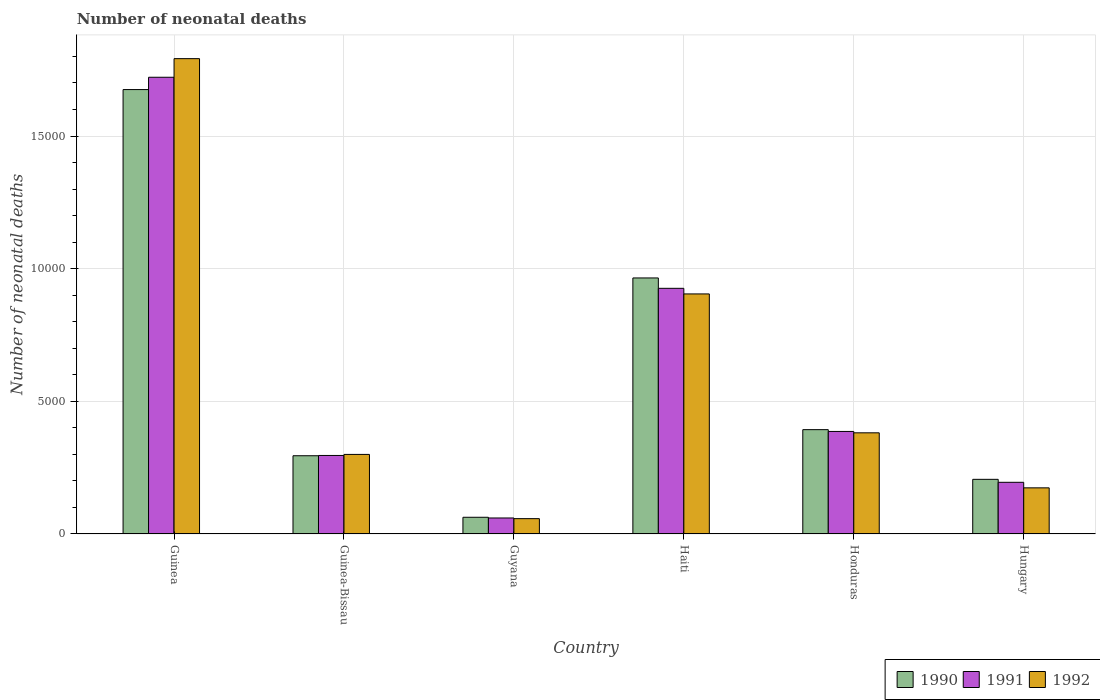How many groups of bars are there?
Provide a succinct answer. 6. Are the number of bars per tick equal to the number of legend labels?
Offer a very short reply. Yes. How many bars are there on the 3rd tick from the right?
Ensure brevity in your answer.  3. What is the label of the 2nd group of bars from the left?
Provide a short and direct response. Guinea-Bissau. What is the number of neonatal deaths in in 1992 in Haiti?
Keep it short and to the point. 9049. Across all countries, what is the maximum number of neonatal deaths in in 1992?
Provide a succinct answer. 1.79e+04. Across all countries, what is the minimum number of neonatal deaths in in 1991?
Offer a very short reply. 603. In which country was the number of neonatal deaths in in 1992 maximum?
Your answer should be compact. Guinea. In which country was the number of neonatal deaths in in 1990 minimum?
Offer a terse response. Guyana. What is the total number of neonatal deaths in in 1992 in the graph?
Keep it short and to the point. 3.61e+04. What is the difference between the number of neonatal deaths in in 1992 in Guinea and that in Guyana?
Keep it short and to the point. 1.73e+04. What is the difference between the number of neonatal deaths in in 1991 in Guinea-Bissau and the number of neonatal deaths in in 1990 in Guinea?
Your answer should be very brief. -1.38e+04. What is the average number of neonatal deaths in in 1990 per country?
Offer a very short reply. 5995.83. What is the difference between the number of neonatal deaths in of/in 1992 and number of neonatal deaths in of/in 1991 in Haiti?
Offer a terse response. -211. What is the ratio of the number of neonatal deaths in in 1991 in Guinea to that in Guinea-Bissau?
Your answer should be compact. 5.82. Is the difference between the number of neonatal deaths in in 1992 in Guinea-Bissau and Guyana greater than the difference between the number of neonatal deaths in in 1991 in Guinea-Bissau and Guyana?
Your answer should be compact. Yes. What is the difference between the highest and the second highest number of neonatal deaths in in 1992?
Ensure brevity in your answer.  5236. What is the difference between the highest and the lowest number of neonatal deaths in in 1992?
Keep it short and to the point. 1.73e+04. In how many countries, is the number of neonatal deaths in in 1992 greater than the average number of neonatal deaths in in 1992 taken over all countries?
Your answer should be compact. 2. Is the sum of the number of neonatal deaths in in 1991 in Guyana and Hungary greater than the maximum number of neonatal deaths in in 1992 across all countries?
Your answer should be compact. No. What does the 1st bar from the left in Guyana represents?
Provide a short and direct response. 1990. Is it the case that in every country, the sum of the number of neonatal deaths in in 1990 and number of neonatal deaths in in 1992 is greater than the number of neonatal deaths in in 1991?
Ensure brevity in your answer.  Yes. Are all the bars in the graph horizontal?
Your answer should be very brief. No. What is the difference between two consecutive major ticks on the Y-axis?
Your answer should be compact. 5000. Are the values on the major ticks of Y-axis written in scientific E-notation?
Offer a terse response. No. Does the graph contain grids?
Provide a short and direct response. Yes. Where does the legend appear in the graph?
Offer a terse response. Bottom right. How many legend labels are there?
Your answer should be very brief. 3. What is the title of the graph?
Give a very brief answer. Number of neonatal deaths. Does "2003" appear as one of the legend labels in the graph?
Ensure brevity in your answer.  No. What is the label or title of the Y-axis?
Your answer should be very brief. Number of neonatal deaths. What is the Number of neonatal deaths of 1990 in Guinea?
Keep it short and to the point. 1.68e+04. What is the Number of neonatal deaths of 1991 in Guinea?
Offer a very short reply. 1.72e+04. What is the Number of neonatal deaths in 1992 in Guinea?
Make the answer very short. 1.79e+04. What is the Number of neonatal deaths in 1990 in Guinea-Bissau?
Keep it short and to the point. 2949. What is the Number of neonatal deaths of 1991 in Guinea-Bissau?
Offer a very short reply. 2960. What is the Number of neonatal deaths in 1992 in Guinea-Bissau?
Keep it short and to the point. 2999. What is the Number of neonatal deaths in 1990 in Guyana?
Offer a terse response. 630. What is the Number of neonatal deaths of 1991 in Guyana?
Give a very brief answer. 603. What is the Number of neonatal deaths of 1992 in Guyana?
Your answer should be compact. 578. What is the Number of neonatal deaths in 1990 in Haiti?
Your answer should be very brief. 9651. What is the Number of neonatal deaths in 1991 in Haiti?
Ensure brevity in your answer.  9260. What is the Number of neonatal deaths of 1992 in Haiti?
Offer a terse response. 9049. What is the Number of neonatal deaths of 1990 in Honduras?
Give a very brief answer. 3933. What is the Number of neonatal deaths in 1991 in Honduras?
Ensure brevity in your answer.  3865. What is the Number of neonatal deaths of 1992 in Honduras?
Your answer should be very brief. 3813. What is the Number of neonatal deaths in 1990 in Hungary?
Your response must be concise. 2060. What is the Number of neonatal deaths in 1991 in Hungary?
Offer a terse response. 1948. What is the Number of neonatal deaths of 1992 in Hungary?
Keep it short and to the point. 1739. Across all countries, what is the maximum Number of neonatal deaths of 1990?
Give a very brief answer. 1.68e+04. Across all countries, what is the maximum Number of neonatal deaths of 1991?
Your answer should be very brief. 1.72e+04. Across all countries, what is the maximum Number of neonatal deaths of 1992?
Offer a terse response. 1.79e+04. Across all countries, what is the minimum Number of neonatal deaths in 1990?
Your answer should be very brief. 630. Across all countries, what is the minimum Number of neonatal deaths in 1991?
Offer a terse response. 603. Across all countries, what is the minimum Number of neonatal deaths in 1992?
Ensure brevity in your answer.  578. What is the total Number of neonatal deaths of 1990 in the graph?
Keep it short and to the point. 3.60e+04. What is the total Number of neonatal deaths of 1991 in the graph?
Your response must be concise. 3.59e+04. What is the total Number of neonatal deaths in 1992 in the graph?
Make the answer very short. 3.61e+04. What is the difference between the Number of neonatal deaths of 1990 in Guinea and that in Guinea-Bissau?
Keep it short and to the point. 1.38e+04. What is the difference between the Number of neonatal deaths of 1991 in Guinea and that in Guinea-Bissau?
Ensure brevity in your answer.  1.43e+04. What is the difference between the Number of neonatal deaths in 1992 in Guinea and that in Guinea-Bissau?
Keep it short and to the point. 1.49e+04. What is the difference between the Number of neonatal deaths in 1990 in Guinea and that in Guyana?
Offer a very short reply. 1.61e+04. What is the difference between the Number of neonatal deaths of 1991 in Guinea and that in Guyana?
Keep it short and to the point. 1.66e+04. What is the difference between the Number of neonatal deaths of 1992 in Guinea and that in Guyana?
Your answer should be very brief. 1.73e+04. What is the difference between the Number of neonatal deaths in 1990 in Guinea and that in Haiti?
Offer a very short reply. 7101. What is the difference between the Number of neonatal deaths in 1991 in Guinea and that in Haiti?
Provide a succinct answer. 7956. What is the difference between the Number of neonatal deaths in 1992 in Guinea and that in Haiti?
Give a very brief answer. 8869. What is the difference between the Number of neonatal deaths in 1990 in Guinea and that in Honduras?
Ensure brevity in your answer.  1.28e+04. What is the difference between the Number of neonatal deaths in 1991 in Guinea and that in Honduras?
Your response must be concise. 1.34e+04. What is the difference between the Number of neonatal deaths of 1992 in Guinea and that in Honduras?
Provide a short and direct response. 1.41e+04. What is the difference between the Number of neonatal deaths in 1990 in Guinea and that in Hungary?
Give a very brief answer. 1.47e+04. What is the difference between the Number of neonatal deaths in 1991 in Guinea and that in Hungary?
Provide a succinct answer. 1.53e+04. What is the difference between the Number of neonatal deaths of 1992 in Guinea and that in Hungary?
Provide a succinct answer. 1.62e+04. What is the difference between the Number of neonatal deaths of 1990 in Guinea-Bissau and that in Guyana?
Keep it short and to the point. 2319. What is the difference between the Number of neonatal deaths of 1991 in Guinea-Bissau and that in Guyana?
Your answer should be very brief. 2357. What is the difference between the Number of neonatal deaths in 1992 in Guinea-Bissau and that in Guyana?
Make the answer very short. 2421. What is the difference between the Number of neonatal deaths in 1990 in Guinea-Bissau and that in Haiti?
Provide a succinct answer. -6702. What is the difference between the Number of neonatal deaths in 1991 in Guinea-Bissau and that in Haiti?
Offer a terse response. -6300. What is the difference between the Number of neonatal deaths of 1992 in Guinea-Bissau and that in Haiti?
Offer a terse response. -6050. What is the difference between the Number of neonatal deaths in 1990 in Guinea-Bissau and that in Honduras?
Keep it short and to the point. -984. What is the difference between the Number of neonatal deaths in 1991 in Guinea-Bissau and that in Honduras?
Keep it short and to the point. -905. What is the difference between the Number of neonatal deaths of 1992 in Guinea-Bissau and that in Honduras?
Provide a succinct answer. -814. What is the difference between the Number of neonatal deaths in 1990 in Guinea-Bissau and that in Hungary?
Provide a short and direct response. 889. What is the difference between the Number of neonatal deaths of 1991 in Guinea-Bissau and that in Hungary?
Your response must be concise. 1012. What is the difference between the Number of neonatal deaths in 1992 in Guinea-Bissau and that in Hungary?
Your answer should be very brief. 1260. What is the difference between the Number of neonatal deaths in 1990 in Guyana and that in Haiti?
Give a very brief answer. -9021. What is the difference between the Number of neonatal deaths of 1991 in Guyana and that in Haiti?
Ensure brevity in your answer.  -8657. What is the difference between the Number of neonatal deaths in 1992 in Guyana and that in Haiti?
Your answer should be compact. -8471. What is the difference between the Number of neonatal deaths in 1990 in Guyana and that in Honduras?
Provide a short and direct response. -3303. What is the difference between the Number of neonatal deaths in 1991 in Guyana and that in Honduras?
Give a very brief answer. -3262. What is the difference between the Number of neonatal deaths in 1992 in Guyana and that in Honduras?
Keep it short and to the point. -3235. What is the difference between the Number of neonatal deaths of 1990 in Guyana and that in Hungary?
Your response must be concise. -1430. What is the difference between the Number of neonatal deaths of 1991 in Guyana and that in Hungary?
Keep it short and to the point. -1345. What is the difference between the Number of neonatal deaths in 1992 in Guyana and that in Hungary?
Your answer should be very brief. -1161. What is the difference between the Number of neonatal deaths in 1990 in Haiti and that in Honduras?
Your response must be concise. 5718. What is the difference between the Number of neonatal deaths of 1991 in Haiti and that in Honduras?
Offer a terse response. 5395. What is the difference between the Number of neonatal deaths in 1992 in Haiti and that in Honduras?
Provide a succinct answer. 5236. What is the difference between the Number of neonatal deaths of 1990 in Haiti and that in Hungary?
Offer a terse response. 7591. What is the difference between the Number of neonatal deaths of 1991 in Haiti and that in Hungary?
Make the answer very short. 7312. What is the difference between the Number of neonatal deaths of 1992 in Haiti and that in Hungary?
Offer a terse response. 7310. What is the difference between the Number of neonatal deaths of 1990 in Honduras and that in Hungary?
Ensure brevity in your answer.  1873. What is the difference between the Number of neonatal deaths in 1991 in Honduras and that in Hungary?
Give a very brief answer. 1917. What is the difference between the Number of neonatal deaths in 1992 in Honduras and that in Hungary?
Keep it short and to the point. 2074. What is the difference between the Number of neonatal deaths of 1990 in Guinea and the Number of neonatal deaths of 1991 in Guinea-Bissau?
Offer a very short reply. 1.38e+04. What is the difference between the Number of neonatal deaths in 1990 in Guinea and the Number of neonatal deaths in 1992 in Guinea-Bissau?
Provide a succinct answer. 1.38e+04. What is the difference between the Number of neonatal deaths of 1991 in Guinea and the Number of neonatal deaths of 1992 in Guinea-Bissau?
Make the answer very short. 1.42e+04. What is the difference between the Number of neonatal deaths of 1990 in Guinea and the Number of neonatal deaths of 1991 in Guyana?
Make the answer very short. 1.61e+04. What is the difference between the Number of neonatal deaths in 1990 in Guinea and the Number of neonatal deaths in 1992 in Guyana?
Your response must be concise. 1.62e+04. What is the difference between the Number of neonatal deaths in 1991 in Guinea and the Number of neonatal deaths in 1992 in Guyana?
Ensure brevity in your answer.  1.66e+04. What is the difference between the Number of neonatal deaths in 1990 in Guinea and the Number of neonatal deaths in 1991 in Haiti?
Your response must be concise. 7492. What is the difference between the Number of neonatal deaths of 1990 in Guinea and the Number of neonatal deaths of 1992 in Haiti?
Provide a short and direct response. 7703. What is the difference between the Number of neonatal deaths of 1991 in Guinea and the Number of neonatal deaths of 1992 in Haiti?
Make the answer very short. 8167. What is the difference between the Number of neonatal deaths in 1990 in Guinea and the Number of neonatal deaths in 1991 in Honduras?
Keep it short and to the point. 1.29e+04. What is the difference between the Number of neonatal deaths in 1990 in Guinea and the Number of neonatal deaths in 1992 in Honduras?
Offer a very short reply. 1.29e+04. What is the difference between the Number of neonatal deaths of 1991 in Guinea and the Number of neonatal deaths of 1992 in Honduras?
Provide a short and direct response. 1.34e+04. What is the difference between the Number of neonatal deaths of 1990 in Guinea and the Number of neonatal deaths of 1991 in Hungary?
Provide a short and direct response. 1.48e+04. What is the difference between the Number of neonatal deaths in 1990 in Guinea and the Number of neonatal deaths in 1992 in Hungary?
Your answer should be compact. 1.50e+04. What is the difference between the Number of neonatal deaths of 1991 in Guinea and the Number of neonatal deaths of 1992 in Hungary?
Your response must be concise. 1.55e+04. What is the difference between the Number of neonatal deaths in 1990 in Guinea-Bissau and the Number of neonatal deaths in 1991 in Guyana?
Your answer should be very brief. 2346. What is the difference between the Number of neonatal deaths of 1990 in Guinea-Bissau and the Number of neonatal deaths of 1992 in Guyana?
Offer a terse response. 2371. What is the difference between the Number of neonatal deaths of 1991 in Guinea-Bissau and the Number of neonatal deaths of 1992 in Guyana?
Keep it short and to the point. 2382. What is the difference between the Number of neonatal deaths of 1990 in Guinea-Bissau and the Number of neonatal deaths of 1991 in Haiti?
Keep it short and to the point. -6311. What is the difference between the Number of neonatal deaths of 1990 in Guinea-Bissau and the Number of neonatal deaths of 1992 in Haiti?
Your response must be concise. -6100. What is the difference between the Number of neonatal deaths of 1991 in Guinea-Bissau and the Number of neonatal deaths of 1992 in Haiti?
Offer a very short reply. -6089. What is the difference between the Number of neonatal deaths in 1990 in Guinea-Bissau and the Number of neonatal deaths in 1991 in Honduras?
Ensure brevity in your answer.  -916. What is the difference between the Number of neonatal deaths of 1990 in Guinea-Bissau and the Number of neonatal deaths of 1992 in Honduras?
Your answer should be very brief. -864. What is the difference between the Number of neonatal deaths of 1991 in Guinea-Bissau and the Number of neonatal deaths of 1992 in Honduras?
Keep it short and to the point. -853. What is the difference between the Number of neonatal deaths of 1990 in Guinea-Bissau and the Number of neonatal deaths of 1991 in Hungary?
Make the answer very short. 1001. What is the difference between the Number of neonatal deaths in 1990 in Guinea-Bissau and the Number of neonatal deaths in 1992 in Hungary?
Provide a succinct answer. 1210. What is the difference between the Number of neonatal deaths in 1991 in Guinea-Bissau and the Number of neonatal deaths in 1992 in Hungary?
Your answer should be compact. 1221. What is the difference between the Number of neonatal deaths of 1990 in Guyana and the Number of neonatal deaths of 1991 in Haiti?
Give a very brief answer. -8630. What is the difference between the Number of neonatal deaths in 1990 in Guyana and the Number of neonatal deaths in 1992 in Haiti?
Your response must be concise. -8419. What is the difference between the Number of neonatal deaths of 1991 in Guyana and the Number of neonatal deaths of 1992 in Haiti?
Keep it short and to the point. -8446. What is the difference between the Number of neonatal deaths of 1990 in Guyana and the Number of neonatal deaths of 1991 in Honduras?
Your answer should be very brief. -3235. What is the difference between the Number of neonatal deaths of 1990 in Guyana and the Number of neonatal deaths of 1992 in Honduras?
Your answer should be very brief. -3183. What is the difference between the Number of neonatal deaths of 1991 in Guyana and the Number of neonatal deaths of 1992 in Honduras?
Provide a succinct answer. -3210. What is the difference between the Number of neonatal deaths in 1990 in Guyana and the Number of neonatal deaths in 1991 in Hungary?
Provide a succinct answer. -1318. What is the difference between the Number of neonatal deaths in 1990 in Guyana and the Number of neonatal deaths in 1992 in Hungary?
Offer a terse response. -1109. What is the difference between the Number of neonatal deaths of 1991 in Guyana and the Number of neonatal deaths of 1992 in Hungary?
Your answer should be very brief. -1136. What is the difference between the Number of neonatal deaths in 1990 in Haiti and the Number of neonatal deaths in 1991 in Honduras?
Your answer should be compact. 5786. What is the difference between the Number of neonatal deaths in 1990 in Haiti and the Number of neonatal deaths in 1992 in Honduras?
Your answer should be compact. 5838. What is the difference between the Number of neonatal deaths in 1991 in Haiti and the Number of neonatal deaths in 1992 in Honduras?
Provide a succinct answer. 5447. What is the difference between the Number of neonatal deaths of 1990 in Haiti and the Number of neonatal deaths of 1991 in Hungary?
Offer a very short reply. 7703. What is the difference between the Number of neonatal deaths of 1990 in Haiti and the Number of neonatal deaths of 1992 in Hungary?
Provide a succinct answer. 7912. What is the difference between the Number of neonatal deaths in 1991 in Haiti and the Number of neonatal deaths in 1992 in Hungary?
Ensure brevity in your answer.  7521. What is the difference between the Number of neonatal deaths in 1990 in Honduras and the Number of neonatal deaths in 1991 in Hungary?
Offer a very short reply. 1985. What is the difference between the Number of neonatal deaths of 1990 in Honduras and the Number of neonatal deaths of 1992 in Hungary?
Provide a succinct answer. 2194. What is the difference between the Number of neonatal deaths in 1991 in Honduras and the Number of neonatal deaths in 1992 in Hungary?
Your answer should be compact. 2126. What is the average Number of neonatal deaths of 1990 per country?
Offer a very short reply. 5995.83. What is the average Number of neonatal deaths of 1991 per country?
Provide a short and direct response. 5975.33. What is the average Number of neonatal deaths of 1992 per country?
Offer a very short reply. 6016. What is the difference between the Number of neonatal deaths of 1990 and Number of neonatal deaths of 1991 in Guinea?
Keep it short and to the point. -464. What is the difference between the Number of neonatal deaths in 1990 and Number of neonatal deaths in 1992 in Guinea?
Offer a very short reply. -1166. What is the difference between the Number of neonatal deaths of 1991 and Number of neonatal deaths of 1992 in Guinea?
Keep it short and to the point. -702. What is the difference between the Number of neonatal deaths in 1991 and Number of neonatal deaths in 1992 in Guinea-Bissau?
Your answer should be compact. -39. What is the difference between the Number of neonatal deaths of 1990 and Number of neonatal deaths of 1991 in Haiti?
Ensure brevity in your answer.  391. What is the difference between the Number of neonatal deaths in 1990 and Number of neonatal deaths in 1992 in Haiti?
Give a very brief answer. 602. What is the difference between the Number of neonatal deaths of 1991 and Number of neonatal deaths of 1992 in Haiti?
Provide a succinct answer. 211. What is the difference between the Number of neonatal deaths of 1990 and Number of neonatal deaths of 1992 in Honduras?
Offer a very short reply. 120. What is the difference between the Number of neonatal deaths of 1990 and Number of neonatal deaths of 1991 in Hungary?
Give a very brief answer. 112. What is the difference between the Number of neonatal deaths of 1990 and Number of neonatal deaths of 1992 in Hungary?
Your response must be concise. 321. What is the difference between the Number of neonatal deaths in 1991 and Number of neonatal deaths in 1992 in Hungary?
Make the answer very short. 209. What is the ratio of the Number of neonatal deaths of 1990 in Guinea to that in Guinea-Bissau?
Ensure brevity in your answer.  5.68. What is the ratio of the Number of neonatal deaths in 1991 in Guinea to that in Guinea-Bissau?
Your answer should be compact. 5.82. What is the ratio of the Number of neonatal deaths of 1992 in Guinea to that in Guinea-Bissau?
Ensure brevity in your answer.  5.97. What is the ratio of the Number of neonatal deaths in 1990 in Guinea to that in Guyana?
Your answer should be very brief. 26.59. What is the ratio of the Number of neonatal deaths of 1991 in Guinea to that in Guyana?
Keep it short and to the point. 28.55. What is the ratio of the Number of neonatal deaths in 1990 in Guinea to that in Haiti?
Your answer should be very brief. 1.74. What is the ratio of the Number of neonatal deaths of 1991 in Guinea to that in Haiti?
Offer a very short reply. 1.86. What is the ratio of the Number of neonatal deaths of 1992 in Guinea to that in Haiti?
Provide a short and direct response. 1.98. What is the ratio of the Number of neonatal deaths of 1990 in Guinea to that in Honduras?
Provide a short and direct response. 4.26. What is the ratio of the Number of neonatal deaths of 1991 in Guinea to that in Honduras?
Your answer should be compact. 4.45. What is the ratio of the Number of neonatal deaths in 1992 in Guinea to that in Honduras?
Offer a terse response. 4.7. What is the ratio of the Number of neonatal deaths of 1990 in Guinea to that in Hungary?
Offer a very short reply. 8.13. What is the ratio of the Number of neonatal deaths in 1991 in Guinea to that in Hungary?
Offer a very short reply. 8.84. What is the ratio of the Number of neonatal deaths of 1992 in Guinea to that in Hungary?
Offer a very short reply. 10.3. What is the ratio of the Number of neonatal deaths of 1990 in Guinea-Bissau to that in Guyana?
Your response must be concise. 4.68. What is the ratio of the Number of neonatal deaths of 1991 in Guinea-Bissau to that in Guyana?
Keep it short and to the point. 4.91. What is the ratio of the Number of neonatal deaths of 1992 in Guinea-Bissau to that in Guyana?
Make the answer very short. 5.19. What is the ratio of the Number of neonatal deaths in 1990 in Guinea-Bissau to that in Haiti?
Your answer should be very brief. 0.31. What is the ratio of the Number of neonatal deaths of 1991 in Guinea-Bissau to that in Haiti?
Offer a very short reply. 0.32. What is the ratio of the Number of neonatal deaths of 1992 in Guinea-Bissau to that in Haiti?
Provide a short and direct response. 0.33. What is the ratio of the Number of neonatal deaths of 1990 in Guinea-Bissau to that in Honduras?
Give a very brief answer. 0.75. What is the ratio of the Number of neonatal deaths in 1991 in Guinea-Bissau to that in Honduras?
Give a very brief answer. 0.77. What is the ratio of the Number of neonatal deaths in 1992 in Guinea-Bissau to that in Honduras?
Give a very brief answer. 0.79. What is the ratio of the Number of neonatal deaths in 1990 in Guinea-Bissau to that in Hungary?
Your answer should be compact. 1.43. What is the ratio of the Number of neonatal deaths in 1991 in Guinea-Bissau to that in Hungary?
Give a very brief answer. 1.52. What is the ratio of the Number of neonatal deaths in 1992 in Guinea-Bissau to that in Hungary?
Provide a succinct answer. 1.72. What is the ratio of the Number of neonatal deaths of 1990 in Guyana to that in Haiti?
Offer a terse response. 0.07. What is the ratio of the Number of neonatal deaths in 1991 in Guyana to that in Haiti?
Your answer should be very brief. 0.07. What is the ratio of the Number of neonatal deaths of 1992 in Guyana to that in Haiti?
Keep it short and to the point. 0.06. What is the ratio of the Number of neonatal deaths in 1990 in Guyana to that in Honduras?
Your answer should be compact. 0.16. What is the ratio of the Number of neonatal deaths in 1991 in Guyana to that in Honduras?
Provide a succinct answer. 0.16. What is the ratio of the Number of neonatal deaths of 1992 in Guyana to that in Honduras?
Give a very brief answer. 0.15. What is the ratio of the Number of neonatal deaths of 1990 in Guyana to that in Hungary?
Ensure brevity in your answer.  0.31. What is the ratio of the Number of neonatal deaths of 1991 in Guyana to that in Hungary?
Make the answer very short. 0.31. What is the ratio of the Number of neonatal deaths in 1992 in Guyana to that in Hungary?
Ensure brevity in your answer.  0.33. What is the ratio of the Number of neonatal deaths in 1990 in Haiti to that in Honduras?
Make the answer very short. 2.45. What is the ratio of the Number of neonatal deaths of 1991 in Haiti to that in Honduras?
Provide a succinct answer. 2.4. What is the ratio of the Number of neonatal deaths in 1992 in Haiti to that in Honduras?
Make the answer very short. 2.37. What is the ratio of the Number of neonatal deaths in 1990 in Haiti to that in Hungary?
Give a very brief answer. 4.68. What is the ratio of the Number of neonatal deaths in 1991 in Haiti to that in Hungary?
Provide a succinct answer. 4.75. What is the ratio of the Number of neonatal deaths in 1992 in Haiti to that in Hungary?
Your answer should be very brief. 5.2. What is the ratio of the Number of neonatal deaths of 1990 in Honduras to that in Hungary?
Offer a terse response. 1.91. What is the ratio of the Number of neonatal deaths of 1991 in Honduras to that in Hungary?
Give a very brief answer. 1.98. What is the ratio of the Number of neonatal deaths of 1992 in Honduras to that in Hungary?
Give a very brief answer. 2.19. What is the difference between the highest and the second highest Number of neonatal deaths of 1990?
Offer a terse response. 7101. What is the difference between the highest and the second highest Number of neonatal deaths of 1991?
Ensure brevity in your answer.  7956. What is the difference between the highest and the second highest Number of neonatal deaths of 1992?
Keep it short and to the point. 8869. What is the difference between the highest and the lowest Number of neonatal deaths of 1990?
Your response must be concise. 1.61e+04. What is the difference between the highest and the lowest Number of neonatal deaths of 1991?
Offer a terse response. 1.66e+04. What is the difference between the highest and the lowest Number of neonatal deaths of 1992?
Offer a very short reply. 1.73e+04. 